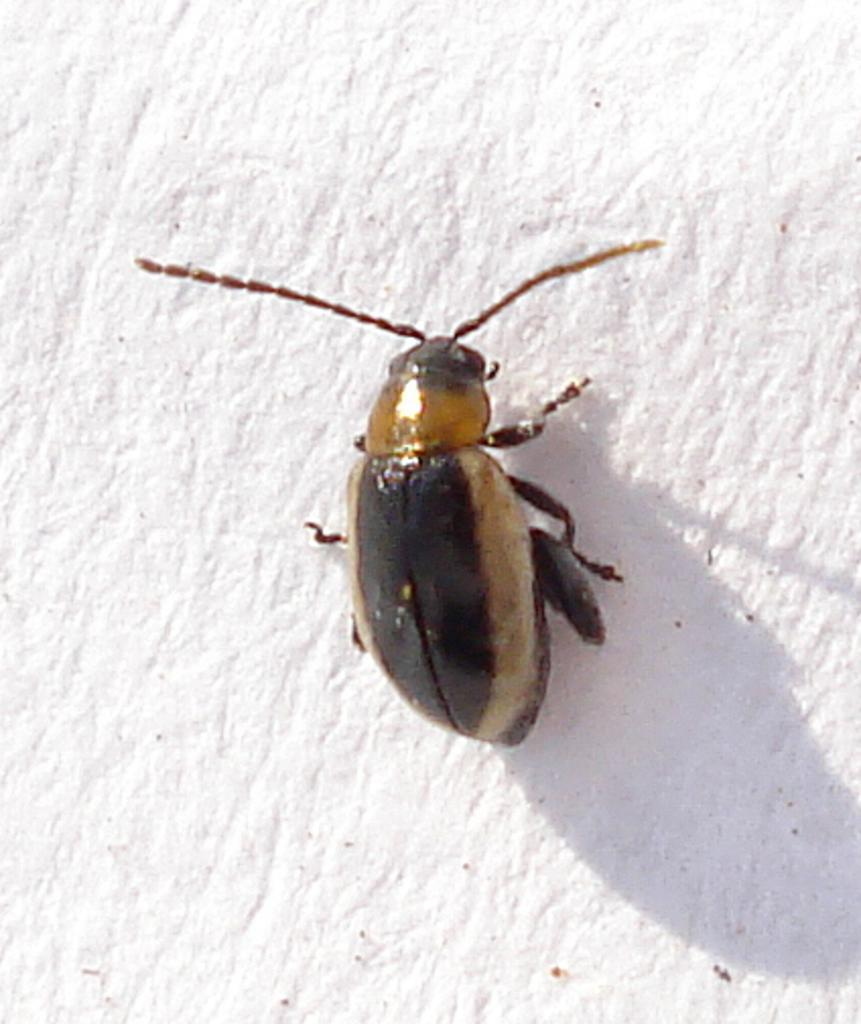What type of creature is present in the image? There is an insect in the picture. What are some physical features of the insect? The insect has legs and a body. What is the background of the image? There is a white surface in the backdrop of the image. What is the name of the insect's daughter in the image? There is no mention of a daughter or any offspring in the image, as it only features an insect with legs and a body against a white background. 